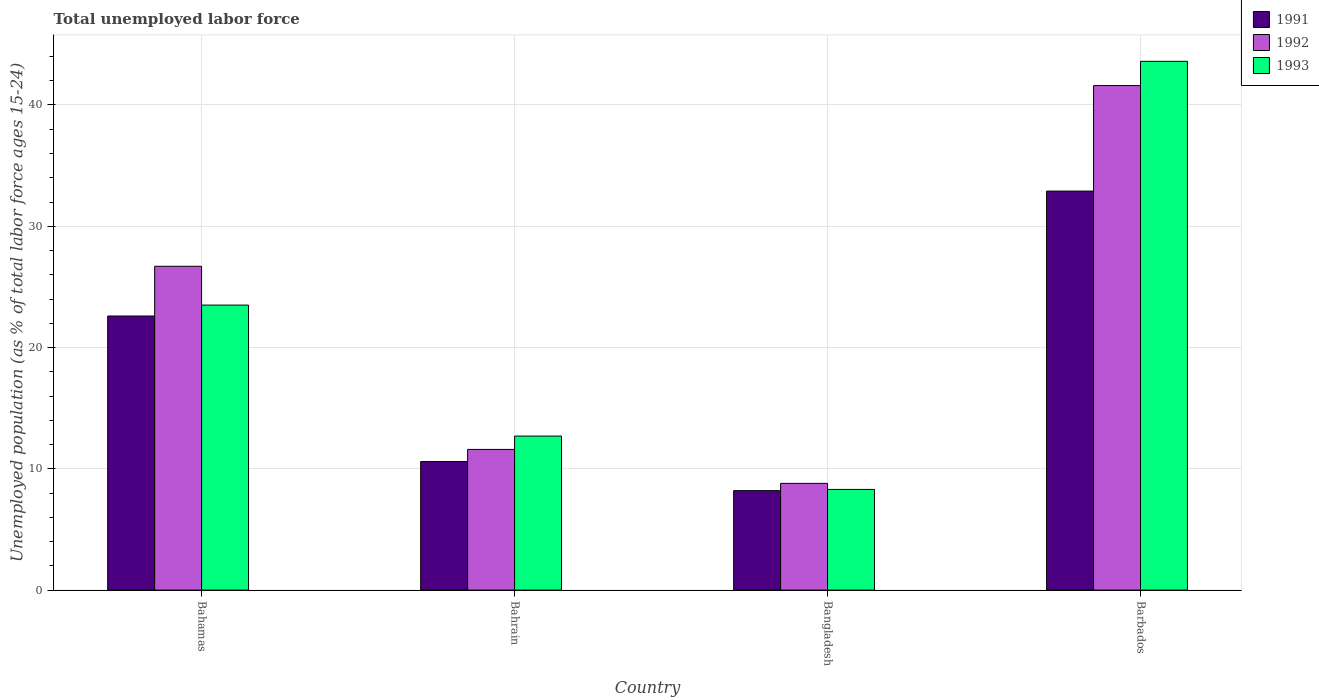How many different coloured bars are there?
Offer a terse response. 3. Are the number of bars on each tick of the X-axis equal?
Ensure brevity in your answer.  Yes. How many bars are there on the 1st tick from the right?
Your answer should be very brief. 3. What is the label of the 3rd group of bars from the left?
Your answer should be very brief. Bangladesh. What is the percentage of unemployed population in in 1992 in Barbados?
Ensure brevity in your answer.  41.6. Across all countries, what is the maximum percentage of unemployed population in in 1991?
Your answer should be compact. 32.9. Across all countries, what is the minimum percentage of unemployed population in in 1993?
Make the answer very short. 8.3. In which country was the percentage of unemployed population in in 1993 maximum?
Your response must be concise. Barbados. What is the total percentage of unemployed population in in 1991 in the graph?
Ensure brevity in your answer.  74.3. What is the difference between the percentage of unemployed population in in 1991 in Bahamas and that in Bahrain?
Your answer should be very brief. 12. What is the difference between the percentage of unemployed population in in 1993 in Bahrain and the percentage of unemployed population in in 1992 in Bangladesh?
Offer a terse response. 3.9. What is the average percentage of unemployed population in in 1991 per country?
Ensure brevity in your answer.  18.58. What is the difference between the percentage of unemployed population in of/in 1991 and percentage of unemployed population in of/in 1993 in Bahamas?
Offer a terse response. -0.9. In how many countries, is the percentage of unemployed population in in 1993 greater than 16 %?
Provide a succinct answer. 2. What is the ratio of the percentage of unemployed population in in 1991 in Bahrain to that in Bangladesh?
Provide a succinct answer. 1.29. What is the difference between the highest and the second highest percentage of unemployed population in in 1992?
Your answer should be very brief. 14.9. What is the difference between the highest and the lowest percentage of unemployed population in in 1993?
Your answer should be compact. 35.3. What does the 1st bar from the left in Barbados represents?
Your answer should be compact. 1991. How many bars are there?
Your answer should be very brief. 12. How many countries are there in the graph?
Keep it short and to the point. 4. Are the values on the major ticks of Y-axis written in scientific E-notation?
Provide a short and direct response. No. Does the graph contain any zero values?
Your answer should be compact. No. Does the graph contain grids?
Make the answer very short. Yes. How are the legend labels stacked?
Ensure brevity in your answer.  Vertical. What is the title of the graph?
Provide a succinct answer. Total unemployed labor force. Does "1981" appear as one of the legend labels in the graph?
Offer a terse response. No. What is the label or title of the Y-axis?
Provide a short and direct response. Unemployed population (as % of total labor force ages 15-24). What is the Unemployed population (as % of total labor force ages 15-24) of 1991 in Bahamas?
Offer a terse response. 22.6. What is the Unemployed population (as % of total labor force ages 15-24) in 1992 in Bahamas?
Keep it short and to the point. 26.7. What is the Unemployed population (as % of total labor force ages 15-24) in 1993 in Bahamas?
Keep it short and to the point. 23.5. What is the Unemployed population (as % of total labor force ages 15-24) in 1991 in Bahrain?
Your response must be concise. 10.6. What is the Unemployed population (as % of total labor force ages 15-24) of 1992 in Bahrain?
Your response must be concise. 11.6. What is the Unemployed population (as % of total labor force ages 15-24) of 1993 in Bahrain?
Your answer should be compact. 12.7. What is the Unemployed population (as % of total labor force ages 15-24) of 1991 in Bangladesh?
Your response must be concise. 8.2. What is the Unemployed population (as % of total labor force ages 15-24) of 1992 in Bangladesh?
Provide a succinct answer. 8.8. What is the Unemployed population (as % of total labor force ages 15-24) in 1993 in Bangladesh?
Give a very brief answer. 8.3. What is the Unemployed population (as % of total labor force ages 15-24) in 1991 in Barbados?
Provide a short and direct response. 32.9. What is the Unemployed population (as % of total labor force ages 15-24) of 1992 in Barbados?
Provide a succinct answer. 41.6. What is the Unemployed population (as % of total labor force ages 15-24) of 1993 in Barbados?
Offer a very short reply. 43.6. Across all countries, what is the maximum Unemployed population (as % of total labor force ages 15-24) in 1991?
Your answer should be compact. 32.9. Across all countries, what is the maximum Unemployed population (as % of total labor force ages 15-24) of 1992?
Give a very brief answer. 41.6. Across all countries, what is the maximum Unemployed population (as % of total labor force ages 15-24) in 1993?
Provide a succinct answer. 43.6. Across all countries, what is the minimum Unemployed population (as % of total labor force ages 15-24) of 1991?
Provide a short and direct response. 8.2. Across all countries, what is the minimum Unemployed population (as % of total labor force ages 15-24) in 1992?
Your response must be concise. 8.8. Across all countries, what is the minimum Unemployed population (as % of total labor force ages 15-24) in 1993?
Provide a short and direct response. 8.3. What is the total Unemployed population (as % of total labor force ages 15-24) of 1991 in the graph?
Offer a very short reply. 74.3. What is the total Unemployed population (as % of total labor force ages 15-24) in 1992 in the graph?
Your answer should be very brief. 88.7. What is the total Unemployed population (as % of total labor force ages 15-24) in 1993 in the graph?
Provide a short and direct response. 88.1. What is the difference between the Unemployed population (as % of total labor force ages 15-24) of 1993 in Bahamas and that in Bangladesh?
Your response must be concise. 15.2. What is the difference between the Unemployed population (as % of total labor force ages 15-24) of 1991 in Bahamas and that in Barbados?
Your response must be concise. -10.3. What is the difference between the Unemployed population (as % of total labor force ages 15-24) of 1992 in Bahamas and that in Barbados?
Make the answer very short. -14.9. What is the difference between the Unemployed population (as % of total labor force ages 15-24) in 1993 in Bahamas and that in Barbados?
Offer a terse response. -20.1. What is the difference between the Unemployed population (as % of total labor force ages 15-24) in 1992 in Bahrain and that in Bangladesh?
Offer a very short reply. 2.8. What is the difference between the Unemployed population (as % of total labor force ages 15-24) of 1993 in Bahrain and that in Bangladesh?
Make the answer very short. 4.4. What is the difference between the Unemployed population (as % of total labor force ages 15-24) of 1991 in Bahrain and that in Barbados?
Ensure brevity in your answer.  -22.3. What is the difference between the Unemployed population (as % of total labor force ages 15-24) in 1993 in Bahrain and that in Barbados?
Offer a terse response. -30.9. What is the difference between the Unemployed population (as % of total labor force ages 15-24) of 1991 in Bangladesh and that in Barbados?
Provide a short and direct response. -24.7. What is the difference between the Unemployed population (as % of total labor force ages 15-24) of 1992 in Bangladesh and that in Barbados?
Provide a succinct answer. -32.8. What is the difference between the Unemployed population (as % of total labor force ages 15-24) of 1993 in Bangladesh and that in Barbados?
Provide a succinct answer. -35.3. What is the difference between the Unemployed population (as % of total labor force ages 15-24) in 1991 in Bahamas and the Unemployed population (as % of total labor force ages 15-24) in 1993 in Bahrain?
Give a very brief answer. 9.9. What is the difference between the Unemployed population (as % of total labor force ages 15-24) in 1992 in Bahamas and the Unemployed population (as % of total labor force ages 15-24) in 1993 in Bahrain?
Offer a very short reply. 14. What is the difference between the Unemployed population (as % of total labor force ages 15-24) of 1991 in Bahamas and the Unemployed population (as % of total labor force ages 15-24) of 1992 in Bangladesh?
Your answer should be very brief. 13.8. What is the difference between the Unemployed population (as % of total labor force ages 15-24) of 1991 in Bahamas and the Unemployed population (as % of total labor force ages 15-24) of 1992 in Barbados?
Your answer should be compact. -19. What is the difference between the Unemployed population (as % of total labor force ages 15-24) in 1991 in Bahamas and the Unemployed population (as % of total labor force ages 15-24) in 1993 in Barbados?
Your response must be concise. -21. What is the difference between the Unemployed population (as % of total labor force ages 15-24) of 1992 in Bahamas and the Unemployed population (as % of total labor force ages 15-24) of 1993 in Barbados?
Give a very brief answer. -16.9. What is the difference between the Unemployed population (as % of total labor force ages 15-24) in 1991 in Bahrain and the Unemployed population (as % of total labor force ages 15-24) in 1993 in Bangladesh?
Provide a succinct answer. 2.3. What is the difference between the Unemployed population (as % of total labor force ages 15-24) in 1992 in Bahrain and the Unemployed population (as % of total labor force ages 15-24) in 1993 in Bangladesh?
Your answer should be compact. 3.3. What is the difference between the Unemployed population (as % of total labor force ages 15-24) of 1991 in Bahrain and the Unemployed population (as % of total labor force ages 15-24) of 1992 in Barbados?
Your answer should be very brief. -31. What is the difference between the Unemployed population (as % of total labor force ages 15-24) of 1991 in Bahrain and the Unemployed population (as % of total labor force ages 15-24) of 1993 in Barbados?
Make the answer very short. -33. What is the difference between the Unemployed population (as % of total labor force ages 15-24) of 1992 in Bahrain and the Unemployed population (as % of total labor force ages 15-24) of 1993 in Barbados?
Make the answer very short. -32. What is the difference between the Unemployed population (as % of total labor force ages 15-24) in 1991 in Bangladesh and the Unemployed population (as % of total labor force ages 15-24) in 1992 in Barbados?
Give a very brief answer. -33.4. What is the difference between the Unemployed population (as % of total labor force ages 15-24) of 1991 in Bangladesh and the Unemployed population (as % of total labor force ages 15-24) of 1993 in Barbados?
Make the answer very short. -35.4. What is the difference between the Unemployed population (as % of total labor force ages 15-24) of 1992 in Bangladesh and the Unemployed population (as % of total labor force ages 15-24) of 1993 in Barbados?
Provide a succinct answer. -34.8. What is the average Unemployed population (as % of total labor force ages 15-24) in 1991 per country?
Your answer should be very brief. 18.57. What is the average Unemployed population (as % of total labor force ages 15-24) of 1992 per country?
Ensure brevity in your answer.  22.18. What is the average Unemployed population (as % of total labor force ages 15-24) of 1993 per country?
Provide a succinct answer. 22.02. What is the difference between the Unemployed population (as % of total labor force ages 15-24) of 1991 and Unemployed population (as % of total labor force ages 15-24) of 1992 in Bahamas?
Give a very brief answer. -4.1. What is the difference between the Unemployed population (as % of total labor force ages 15-24) of 1991 and Unemployed population (as % of total labor force ages 15-24) of 1993 in Bahamas?
Provide a succinct answer. -0.9. What is the difference between the Unemployed population (as % of total labor force ages 15-24) in 1992 and Unemployed population (as % of total labor force ages 15-24) in 1993 in Bahamas?
Provide a succinct answer. 3.2. What is the difference between the Unemployed population (as % of total labor force ages 15-24) in 1991 and Unemployed population (as % of total labor force ages 15-24) in 1992 in Bahrain?
Make the answer very short. -1. What is the difference between the Unemployed population (as % of total labor force ages 15-24) of 1991 and Unemployed population (as % of total labor force ages 15-24) of 1993 in Bahrain?
Provide a short and direct response. -2.1. What is the difference between the Unemployed population (as % of total labor force ages 15-24) in 1992 and Unemployed population (as % of total labor force ages 15-24) in 1993 in Bahrain?
Your response must be concise. -1.1. What is the difference between the Unemployed population (as % of total labor force ages 15-24) in 1991 and Unemployed population (as % of total labor force ages 15-24) in 1992 in Bangladesh?
Keep it short and to the point. -0.6. What is the difference between the Unemployed population (as % of total labor force ages 15-24) of 1991 and Unemployed population (as % of total labor force ages 15-24) of 1993 in Bangladesh?
Provide a succinct answer. -0.1. What is the difference between the Unemployed population (as % of total labor force ages 15-24) of 1992 and Unemployed population (as % of total labor force ages 15-24) of 1993 in Bangladesh?
Keep it short and to the point. 0.5. What is the difference between the Unemployed population (as % of total labor force ages 15-24) of 1991 and Unemployed population (as % of total labor force ages 15-24) of 1992 in Barbados?
Give a very brief answer. -8.7. What is the ratio of the Unemployed population (as % of total labor force ages 15-24) in 1991 in Bahamas to that in Bahrain?
Your response must be concise. 2.13. What is the ratio of the Unemployed population (as % of total labor force ages 15-24) of 1992 in Bahamas to that in Bahrain?
Keep it short and to the point. 2.3. What is the ratio of the Unemployed population (as % of total labor force ages 15-24) of 1993 in Bahamas to that in Bahrain?
Provide a succinct answer. 1.85. What is the ratio of the Unemployed population (as % of total labor force ages 15-24) in 1991 in Bahamas to that in Bangladesh?
Offer a very short reply. 2.76. What is the ratio of the Unemployed population (as % of total labor force ages 15-24) in 1992 in Bahamas to that in Bangladesh?
Ensure brevity in your answer.  3.03. What is the ratio of the Unemployed population (as % of total labor force ages 15-24) in 1993 in Bahamas to that in Bangladesh?
Make the answer very short. 2.83. What is the ratio of the Unemployed population (as % of total labor force ages 15-24) in 1991 in Bahamas to that in Barbados?
Make the answer very short. 0.69. What is the ratio of the Unemployed population (as % of total labor force ages 15-24) of 1992 in Bahamas to that in Barbados?
Offer a terse response. 0.64. What is the ratio of the Unemployed population (as % of total labor force ages 15-24) in 1993 in Bahamas to that in Barbados?
Provide a short and direct response. 0.54. What is the ratio of the Unemployed population (as % of total labor force ages 15-24) in 1991 in Bahrain to that in Bangladesh?
Give a very brief answer. 1.29. What is the ratio of the Unemployed population (as % of total labor force ages 15-24) in 1992 in Bahrain to that in Bangladesh?
Provide a short and direct response. 1.32. What is the ratio of the Unemployed population (as % of total labor force ages 15-24) of 1993 in Bahrain to that in Bangladesh?
Give a very brief answer. 1.53. What is the ratio of the Unemployed population (as % of total labor force ages 15-24) of 1991 in Bahrain to that in Barbados?
Offer a very short reply. 0.32. What is the ratio of the Unemployed population (as % of total labor force ages 15-24) in 1992 in Bahrain to that in Barbados?
Keep it short and to the point. 0.28. What is the ratio of the Unemployed population (as % of total labor force ages 15-24) of 1993 in Bahrain to that in Barbados?
Offer a very short reply. 0.29. What is the ratio of the Unemployed population (as % of total labor force ages 15-24) in 1991 in Bangladesh to that in Barbados?
Make the answer very short. 0.25. What is the ratio of the Unemployed population (as % of total labor force ages 15-24) of 1992 in Bangladesh to that in Barbados?
Offer a terse response. 0.21. What is the ratio of the Unemployed population (as % of total labor force ages 15-24) in 1993 in Bangladesh to that in Barbados?
Give a very brief answer. 0.19. What is the difference between the highest and the second highest Unemployed population (as % of total labor force ages 15-24) in 1991?
Your answer should be compact. 10.3. What is the difference between the highest and the second highest Unemployed population (as % of total labor force ages 15-24) of 1993?
Your response must be concise. 20.1. What is the difference between the highest and the lowest Unemployed population (as % of total labor force ages 15-24) of 1991?
Make the answer very short. 24.7. What is the difference between the highest and the lowest Unemployed population (as % of total labor force ages 15-24) of 1992?
Offer a terse response. 32.8. What is the difference between the highest and the lowest Unemployed population (as % of total labor force ages 15-24) of 1993?
Your answer should be very brief. 35.3. 